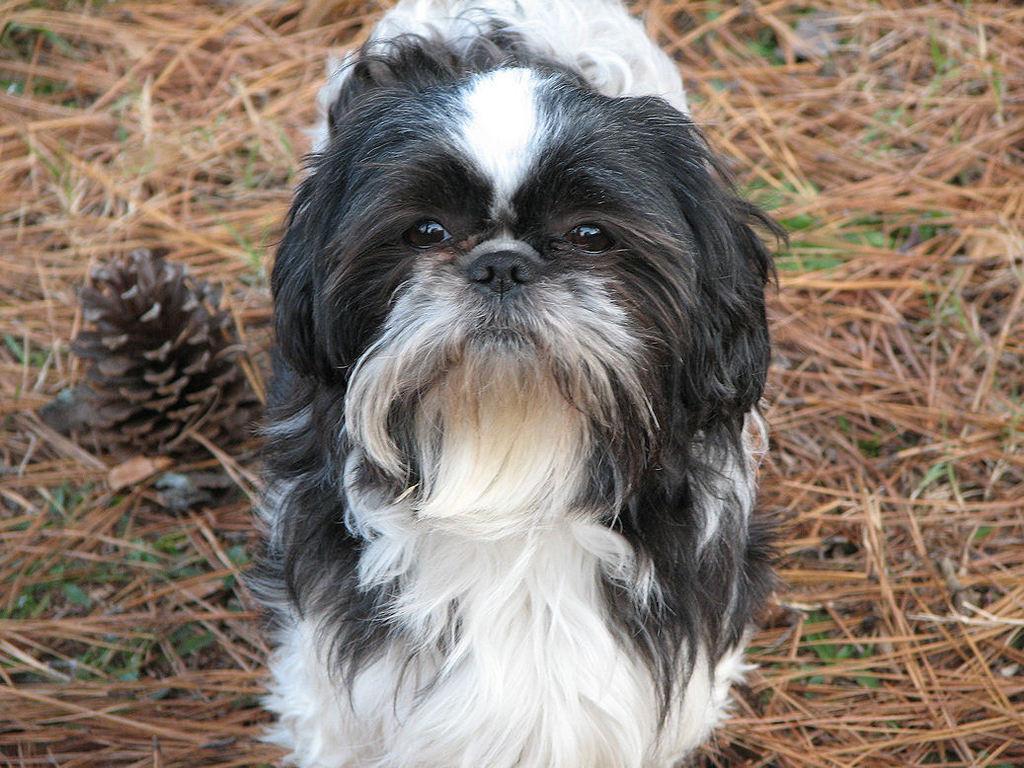Describe this image in one or two sentences. There is a white and a black dog. On the ground there is grass. Also there is a pine corn. 